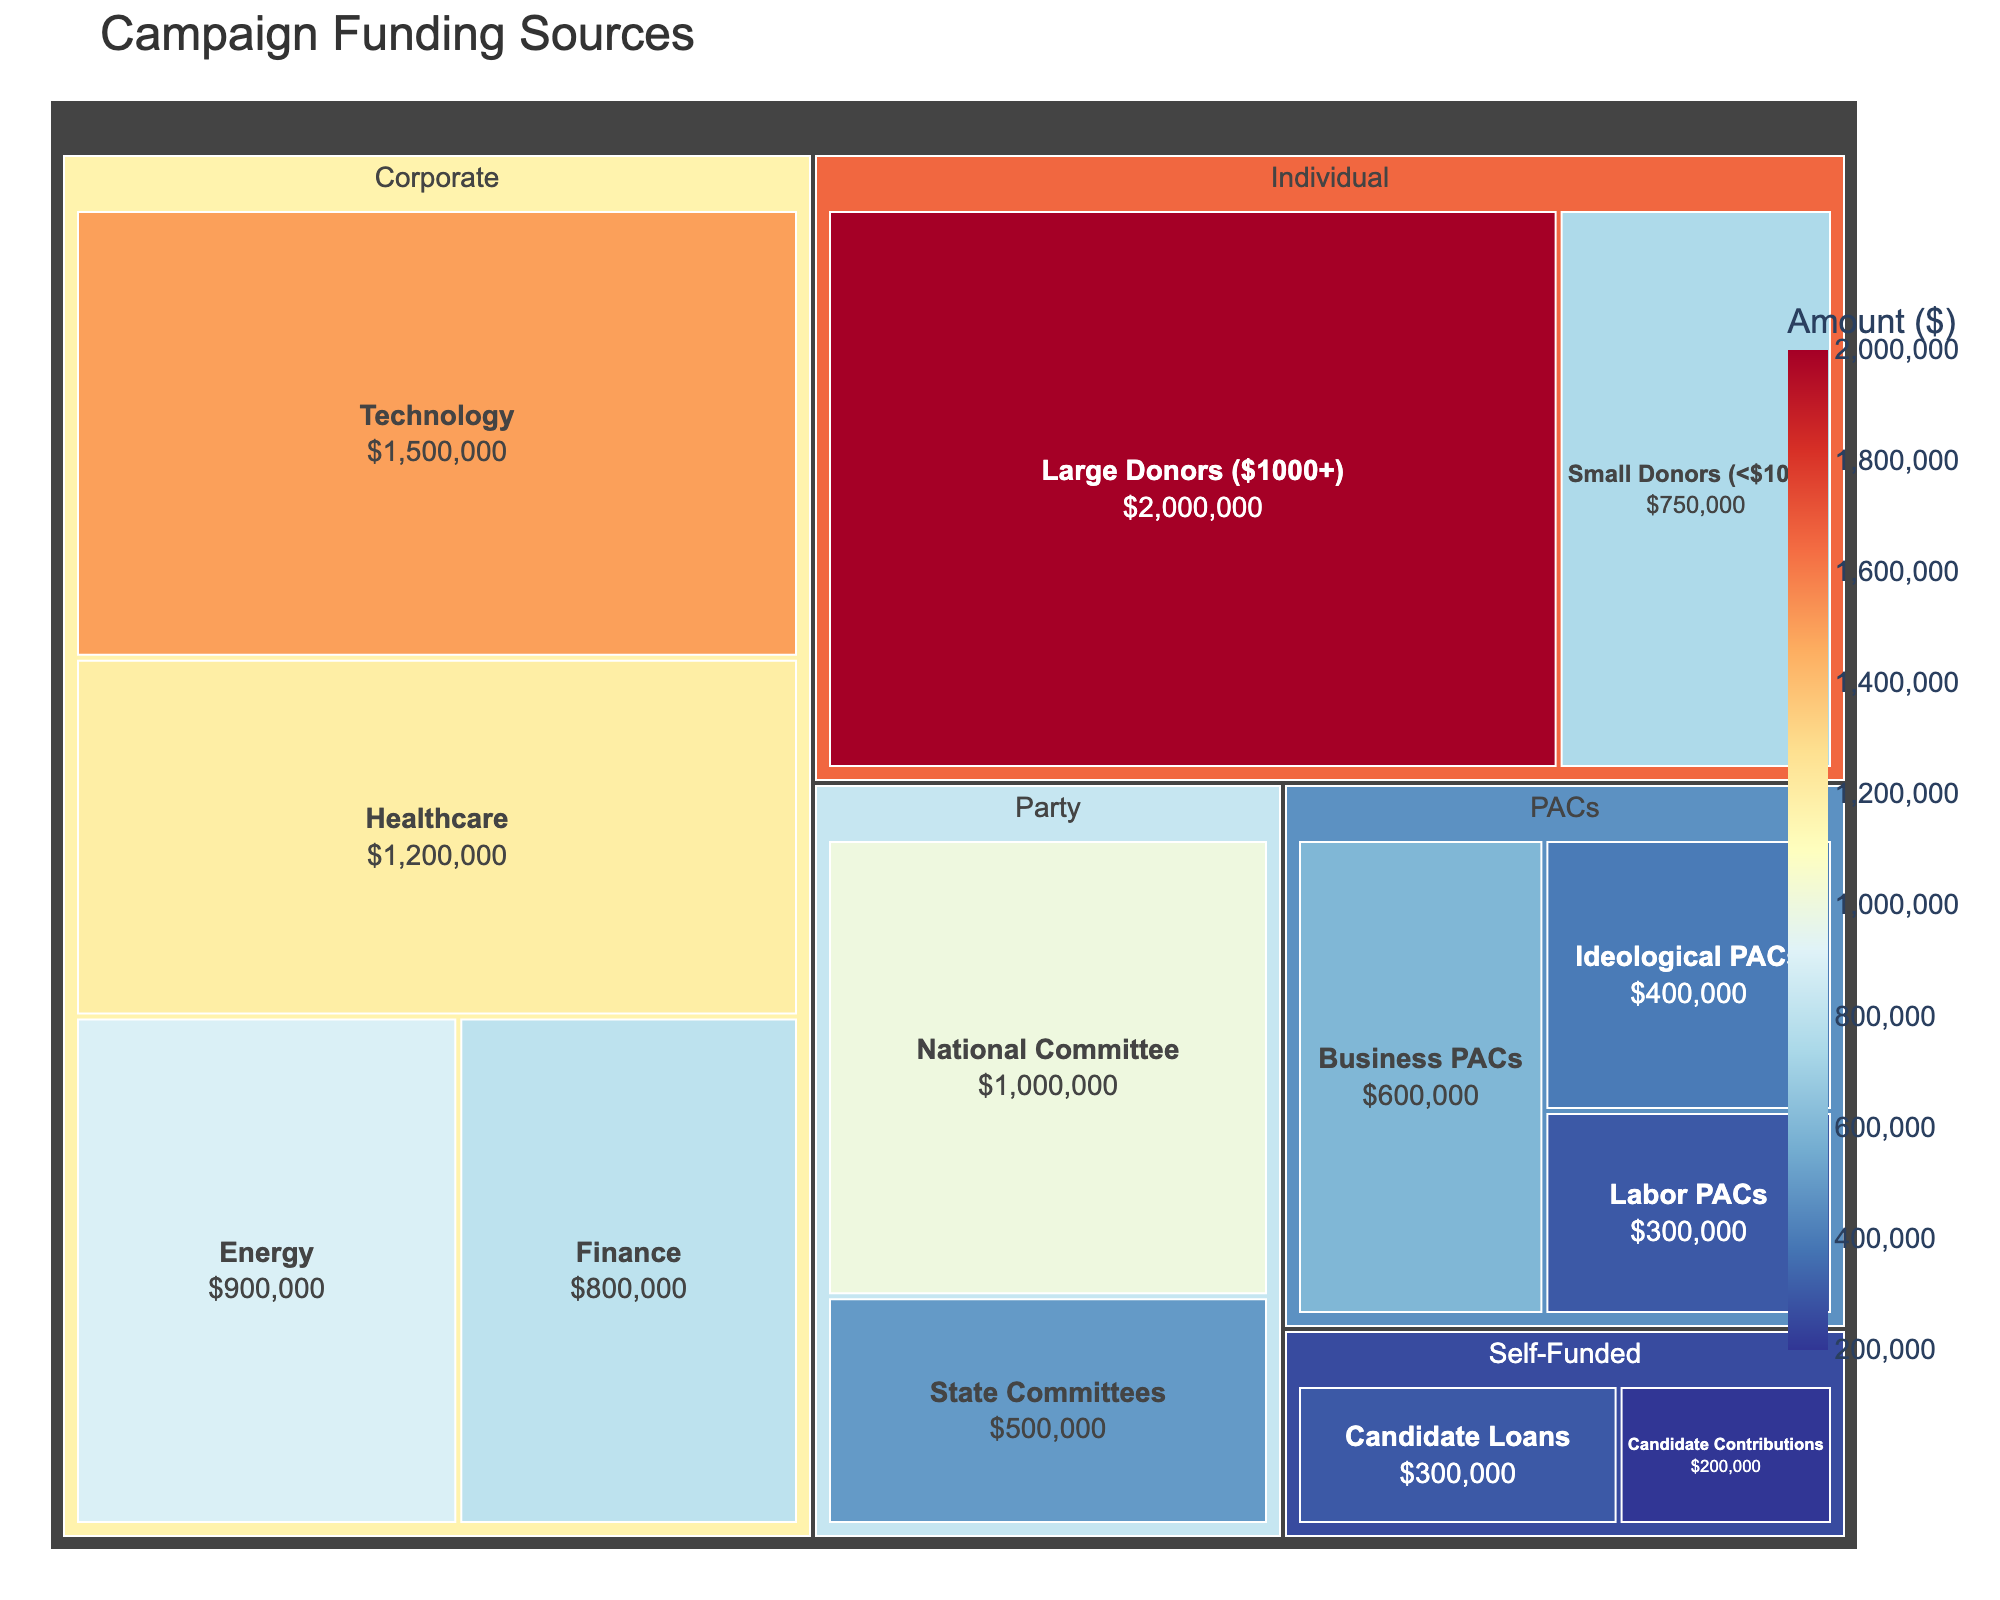What's the largest source of campaign funding? The largest source of campaign funding is shown by the largest section in the treemap. The "Large Donors ($1000+)" under the "Individual" category has the largest rectangle.
Answer: Large Donors ($1000+) How much funding comes from Technology companies? Look at the "Technology" section under the "Corporate" industry within the treemap. The value is directly displayed as the size of the rectangle and the corresponding hover text.
Answer: $1,500,000 Which industry sector contributes the least amount in PACs? Compare the sizes of all industry sectors under "PACs." The smallest sector is "Labor PACs."
Answer: Labor PACs What is the total funding from individual contributions? Sum the amounts from "Large Donors ($1000+)" and "Small Donors (<$1000)" under the "Individual" category: \(2,000,000 + 750,000\).
Answer: $2,750,000 How does the funding from "Candidate Loans" compare to "Candidate Contributions"? The "Candidate Loans" section is larger than the "Candidate Contributions" section. The amounts are $300,000 and $200,000, respectively. Subtract $200,000 from $300,000 to find the difference.
Answer: $100,000 more What proportion of Corporate funding comes from the Healthcare sector? Divide the Healthcare contribution ($1,200,000) by the total Corporate contributions ($1,500,000 + $1,200,000 + $900,000 + $800,000) and multiply by 100 to get the percentage. \((1,200,000 / 4,400,000) * 100\).
Answer: Approximately 27.3% Which category under "PACs" has the highest amount? In the treemap under "PACs," compare the sizes of the sections. "Business PACs" has the largest size.
Answer: Business PACs How much campaign funding is provided by Party Committees in total? Add the contributions from "National Committee" and "State Committees" under the "Party" category: \(1,000,000 + 500,000\)
Answer: $1,500,000 What's the average contribution amount for the sectors under the Corporate industry? Sum the contributions from all Corporate sectors and divide by the number of sectors: \((1,500,000 + 1,200,000 + 900,000 + 800,000) / 4\)
Answer: $1,100,000 Which source of funding has the second largest contribution? Identify the largest contribution and then look for the next largest in the treemap. The largest is "Large Donors ($1000+)," and the second largest is "Technology."
Answer: Technology 